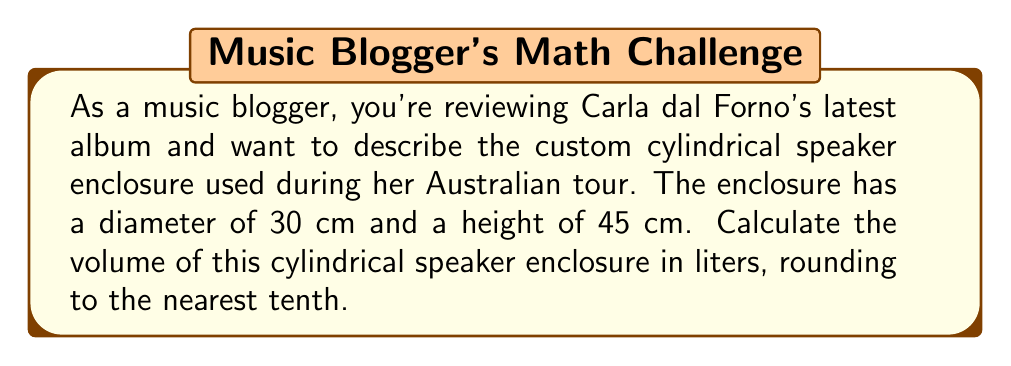Could you help me with this problem? To calculate the volume of a cylindrical speaker enclosure, we'll follow these steps:

1. Recall the formula for the volume of a cylinder:
   $$V = \pi r^2 h$$
   where $V$ is volume, $r$ is radius, and $h$ is height.

2. Convert the diameter to radius:
   Diameter = 30 cm
   $$r = \frac{30}{2} = 15 \text{ cm}$$

3. Use the given height:
   $$h = 45 \text{ cm}$$

4. Substitute these values into the formula:
   $$V = \pi \cdot (15 \text{ cm})^2 \cdot 45 \text{ cm}$$

5. Calculate:
   $$V = \pi \cdot 225 \text{ cm}^2 \cdot 45 \text{ cm}$$
   $$V = 31,808.63 \text{ cm}^3$$

6. Convert cubic centimeters to liters:
   $$31,808.63 \text{ cm}^3 \cdot \frac{1 \text{ L}}{1000 \text{ cm}^3} = 31.81 \text{ L}$$

7. Round to the nearest tenth:
   $$31.8 \text{ L}$$
Answer: 31.8 L 